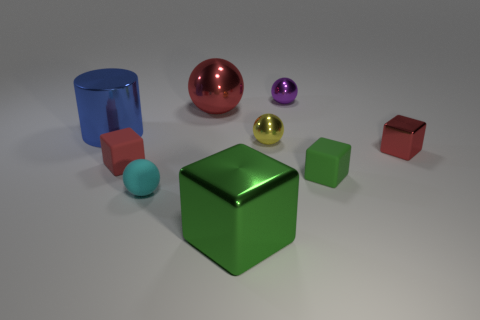Subtract all small cubes. How many cubes are left? 1 Subtract all blue cylinders. How many red blocks are left? 2 Add 1 cyan rubber balls. How many objects exist? 10 Subtract 1 balls. How many balls are left? 3 Subtract all yellow spheres. How many spheres are left? 3 Subtract all cylinders. How many objects are left? 8 Add 8 red spheres. How many red spheres are left? 9 Add 8 yellow spheres. How many yellow spheres exist? 9 Subtract 1 blue cylinders. How many objects are left? 8 Subtract all purple spheres. Subtract all yellow blocks. How many spheres are left? 3 